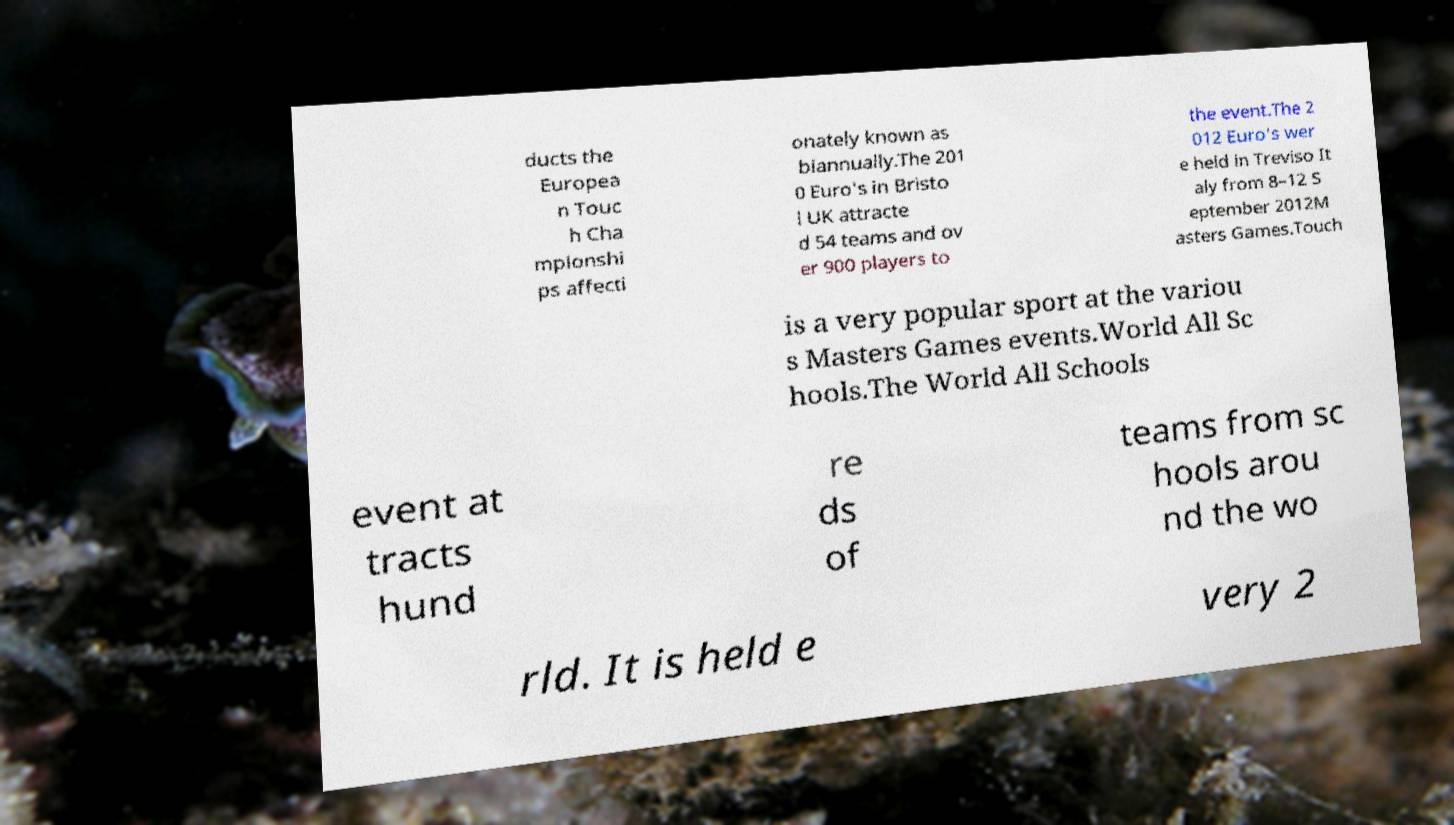I need the written content from this picture converted into text. Can you do that? ducts the Europea n Touc h Cha mpionshi ps affecti onately known as biannually.The 201 0 Euro's in Bristo l UK attracte d 54 teams and ov er 900 players to the event.The 2 012 Euro's wer e held in Treviso It aly from 8–12 S eptember 2012M asters Games.Touch is a very popular sport at the variou s Masters Games events.World All Sc hools.The World All Schools event at tracts hund re ds of teams from sc hools arou nd the wo rld. It is held e very 2 